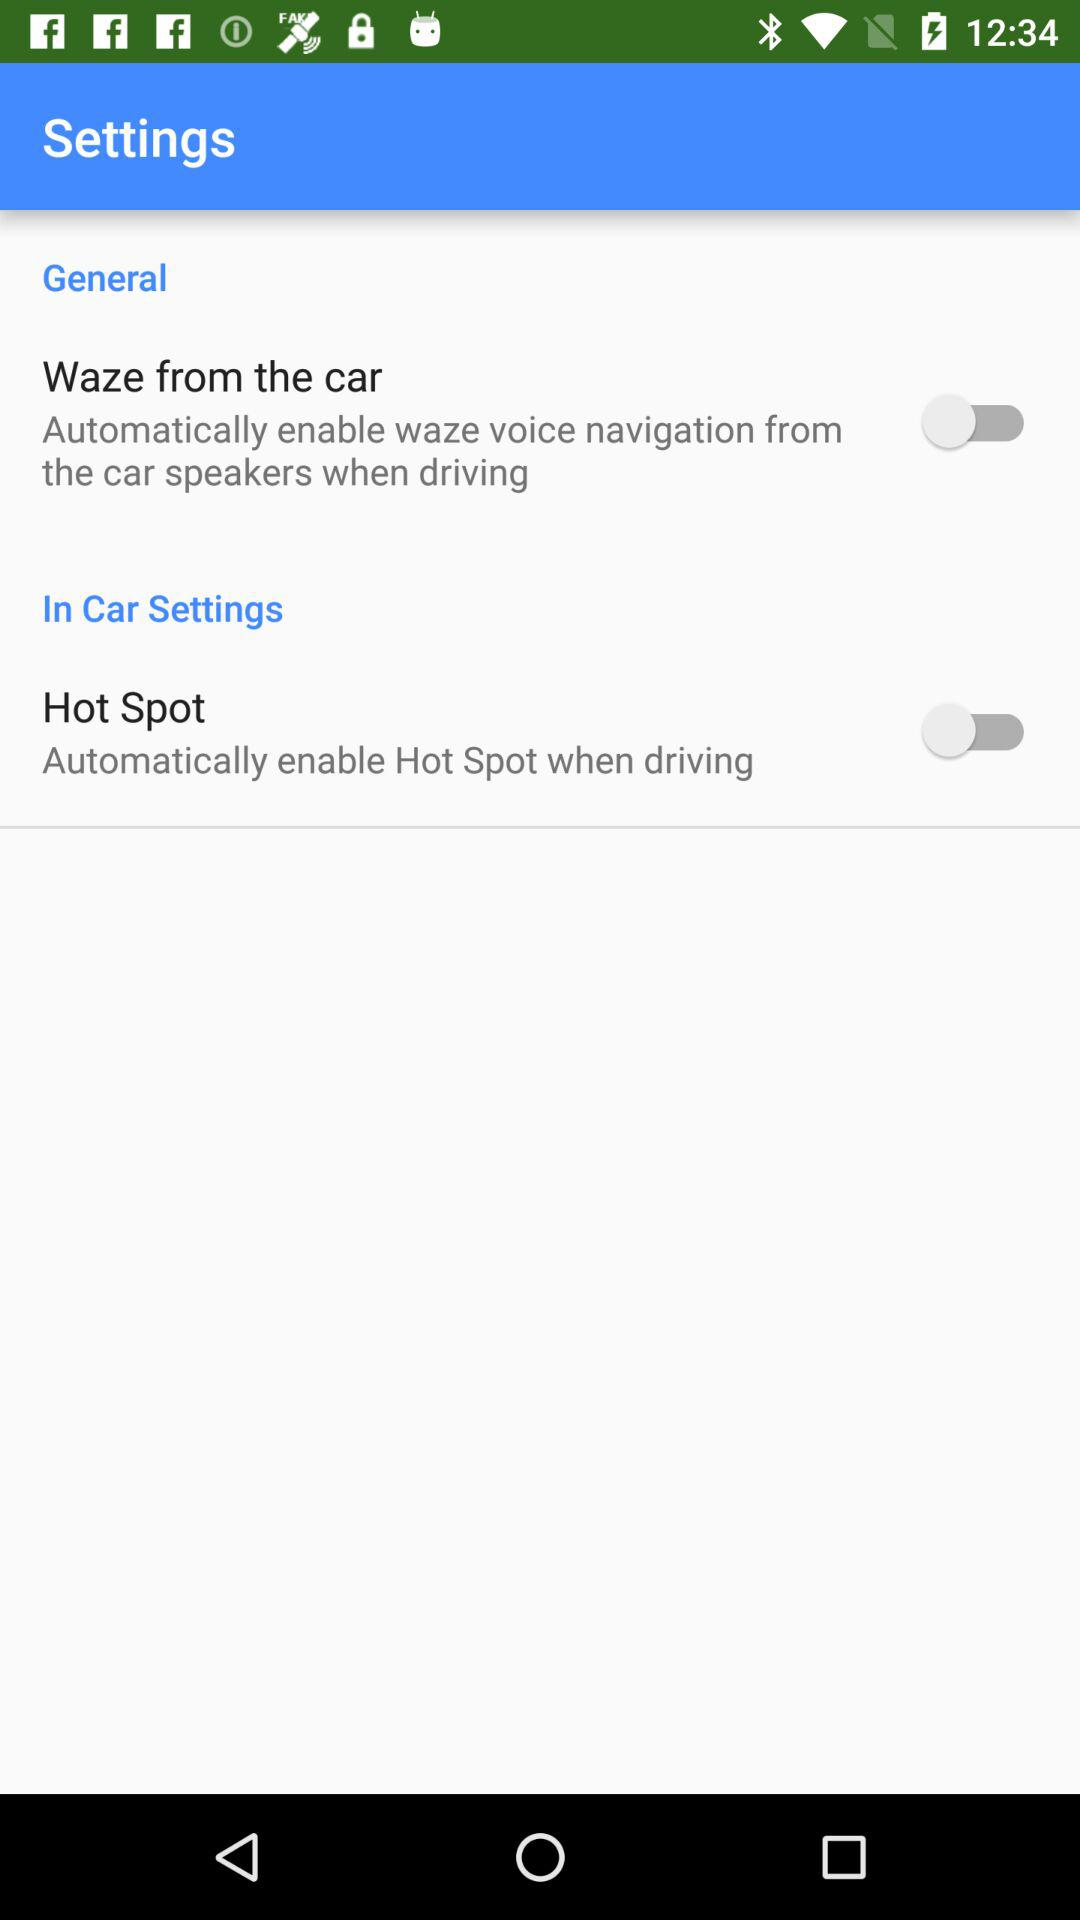What is the status of the "Hot Spot"? The status is "off". 